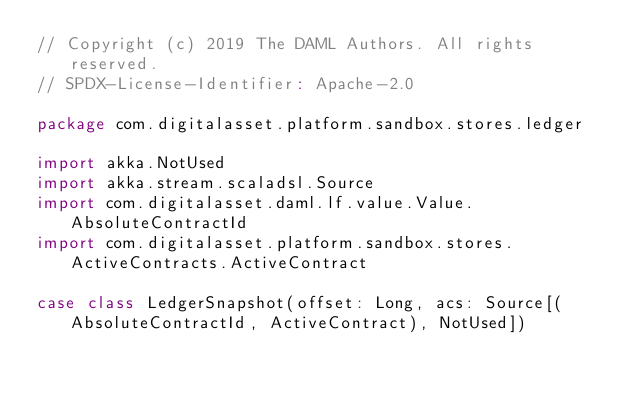<code> <loc_0><loc_0><loc_500><loc_500><_Scala_>// Copyright (c) 2019 The DAML Authors. All rights reserved.
// SPDX-License-Identifier: Apache-2.0

package com.digitalasset.platform.sandbox.stores.ledger

import akka.NotUsed
import akka.stream.scaladsl.Source
import com.digitalasset.daml.lf.value.Value.AbsoluteContractId
import com.digitalasset.platform.sandbox.stores.ActiveContracts.ActiveContract

case class LedgerSnapshot(offset: Long, acs: Source[(AbsoluteContractId, ActiveContract), NotUsed])
</code> 